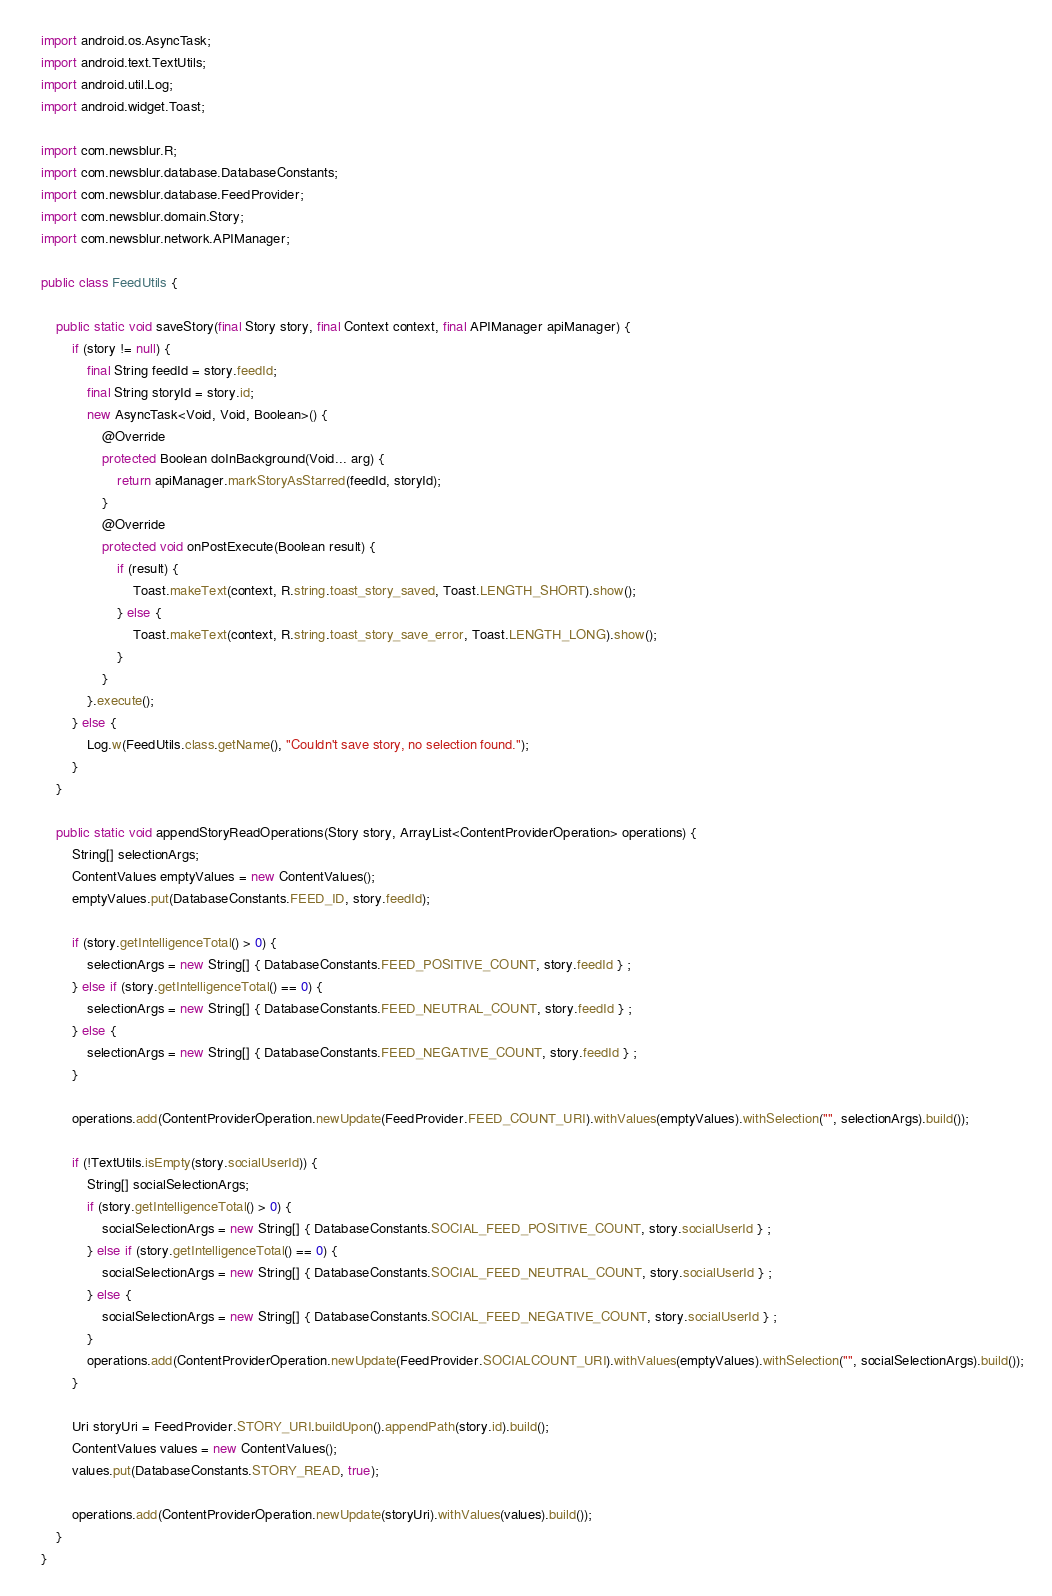<code> <loc_0><loc_0><loc_500><loc_500><_Java_>import android.os.AsyncTask;
import android.text.TextUtils;
import android.util.Log;
import android.widget.Toast;

import com.newsblur.R;
import com.newsblur.database.DatabaseConstants;
import com.newsblur.database.FeedProvider;
import com.newsblur.domain.Story;
import com.newsblur.network.APIManager;

public class FeedUtils {

	public static void saveStory(final Story story, final Context context, final APIManager apiManager) {
		if (story != null) {
            final String feedId = story.feedId;
            final String storyId = story.id;
            new AsyncTask<Void, Void, Boolean>() {
                @Override
                protected Boolean doInBackground(Void... arg) {
                    return apiManager.markStoryAsStarred(feedId, storyId);
                }
                @Override
                protected void onPostExecute(Boolean result) {
                    if (result) {
                        Toast.makeText(context, R.string.toast_story_saved, Toast.LENGTH_SHORT).show();
                    } else {
                        Toast.makeText(context, R.string.toast_story_save_error, Toast.LENGTH_LONG).show();
                    }
                }
            }.execute();
        } else {
            Log.w(FeedUtils.class.getName(), "Couldn't save story, no selection found.");
        }
	}

	public static void appendStoryReadOperations(Story story, ArrayList<ContentProviderOperation> operations) {
		String[] selectionArgs; 
		ContentValues emptyValues = new ContentValues();
		emptyValues.put(DatabaseConstants.FEED_ID, story.feedId);

		if (story.getIntelligenceTotal() > 0) {
			selectionArgs = new String[] { DatabaseConstants.FEED_POSITIVE_COUNT, story.feedId } ; 
		} else if (story.getIntelligenceTotal() == 0) {
			selectionArgs = new String[] { DatabaseConstants.FEED_NEUTRAL_COUNT, story.feedId } ;
		} else {
			selectionArgs = new String[] { DatabaseConstants.FEED_NEGATIVE_COUNT, story.feedId } ;
		}
		
		operations.add(ContentProviderOperation.newUpdate(FeedProvider.FEED_COUNT_URI).withValues(emptyValues).withSelection("", selectionArgs).build());

		if (!TextUtils.isEmpty(story.socialUserId)) {
			String[] socialSelectionArgs; 
			if (story.getIntelligenceTotal() > 0) {
				socialSelectionArgs = new String[] { DatabaseConstants.SOCIAL_FEED_POSITIVE_COUNT, story.socialUserId } ; 
			} else if (story.getIntelligenceTotal() == 0) {
				socialSelectionArgs = new String[] { DatabaseConstants.SOCIAL_FEED_NEUTRAL_COUNT, story.socialUserId } ;
			} else {
				socialSelectionArgs = new String[] { DatabaseConstants.SOCIAL_FEED_NEGATIVE_COUNT, story.socialUserId } ;
			}
			operations.add(ContentProviderOperation.newUpdate(FeedProvider.SOCIALCOUNT_URI).withValues(emptyValues).withSelection("", socialSelectionArgs).build());
		}

		Uri storyUri = FeedProvider.STORY_URI.buildUpon().appendPath(story.id).build();
		ContentValues values = new ContentValues();
		values.put(DatabaseConstants.STORY_READ, true);

		operations.add(ContentProviderOperation.newUpdate(storyUri).withValues(values).build());
	}
}
</code> 